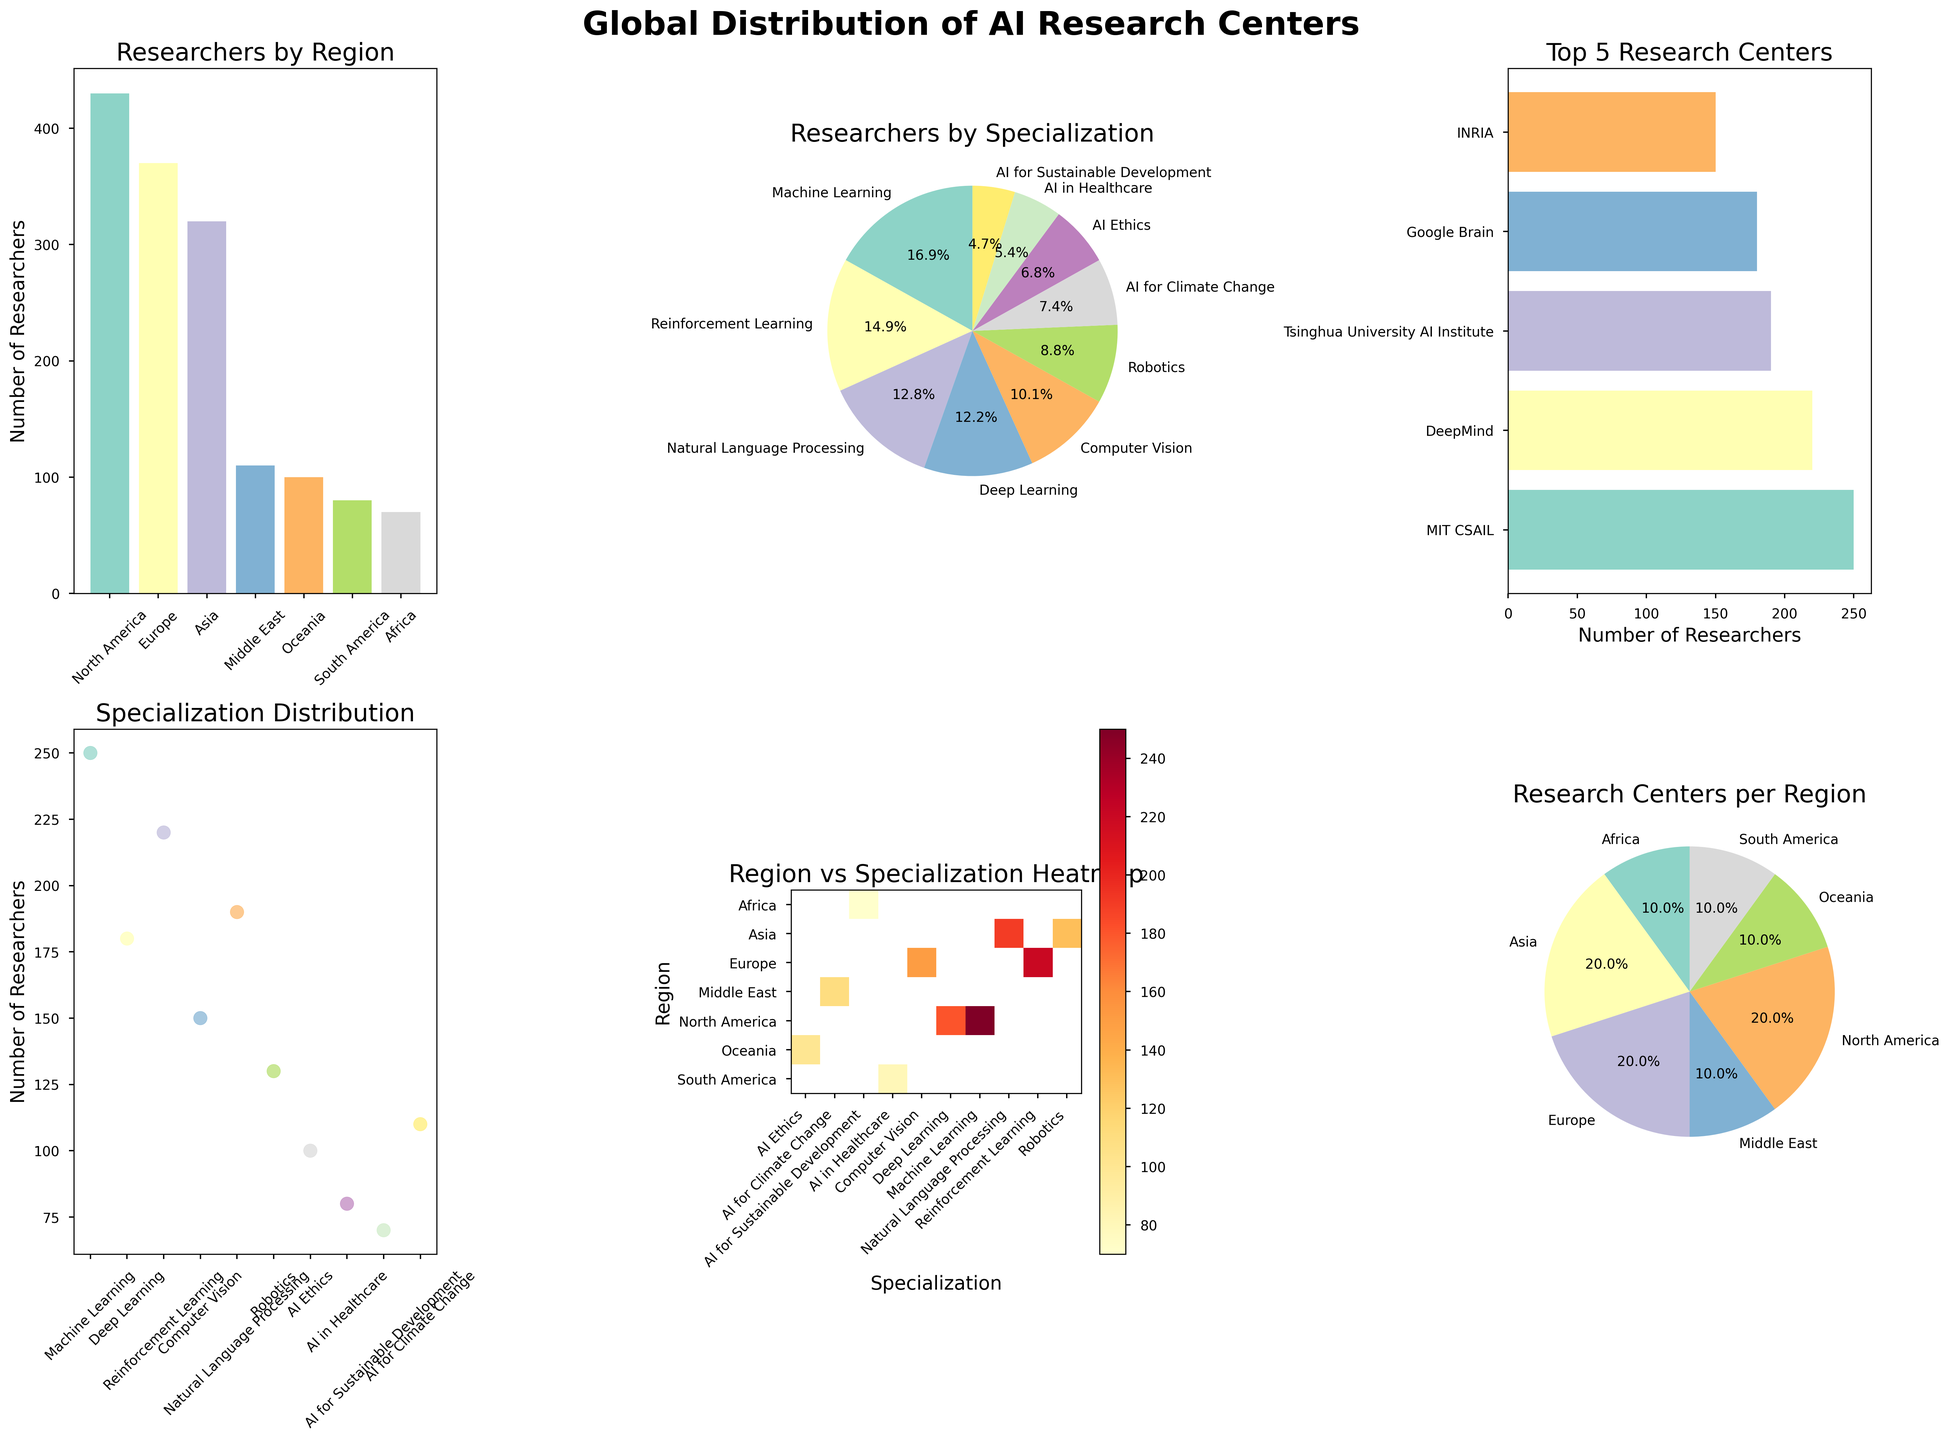Which region has the highest number of researchers? From the "Researchers by Region" bar chart, it's clear that North America has the highest bar indicating the largest number of researchers compared to other regions.
Answer: North America What percentage of researchers specialize in Computer Vision? Refer to the "Researchers by Specialization" pie chart and identify the segment labeled "Computer Vision". The percentage value is displayed on the chart.
Answer: 12.6% Which research center ranks third in terms of number of researchers? The "Top 5 Research Centers" horizontal bar chart lists research centers in descending order of the number of researchers. The third bar corresponds to DeepMind.
Answer: DeepMind How many regions have research centers focusing on AI for Sustainable Development? In the "Region vs Specialization Heatmap", look for the specialization labeled "AI for Sustainable Development" and count the highlighted cells. There is only one in Africa.
Answer: 1 Which specialization has the lowest number of researchers? Check the "Researchers by Specialization" pie chart; the smallest segment corresponds to "AI Ethics".
Answer: AI Ethics How does the number of researchers specializing in Machine Learning compare to Deep Learning? In the "Researchers by Specialization" pie chart, compare the sizes of the segments labeled "Machine Learning" and "Deep Learning". The segment for "Machine Learning" is larger than for "Deep Learning".
Answer: Larger What's the total number of researchers in Asia? Sum the values of Tsinghua University AI Institute (190) and RIKEN AIP (130) as shown in the "Researchers by Region" bar chart. The total is 190 + 130 = 320.
Answer: 320 List all regions that have research centers with fewer than 100 researchers. In the "Research Centers per Region" pie chart, identify regions with percentages that correspond to fewer than 100 researchers: South America and Africa.
Answer: South America, Africa Which research center is represented by the largest bubble in the Specialization Distribution scatter plot? Identify the largest bubble on the "Specialization Distribution" scatter plot; it corresponds to MIT CSAIL.
Answer: MIT CSAIL In which specialization does Europe have the most researchers? Consult the "Region vs Specialization Heatmap" and identify the highest value for Europe across different specializations. It’s Reinforcement Learning.
Answer: Reinforcement Learning 